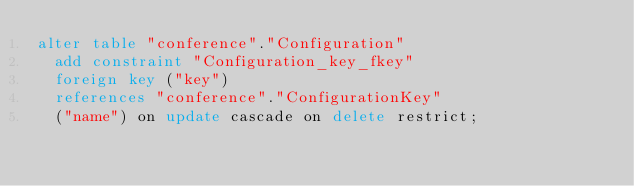Convert code to text. <code><loc_0><loc_0><loc_500><loc_500><_SQL_>alter table "conference"."Configuration"
  add constraint "Configuration_key_fkey"
  foreign key ("key")
  references "conference"."ConfigurationKey"
  ("name") on update cascade on delete restrict;
</code> 